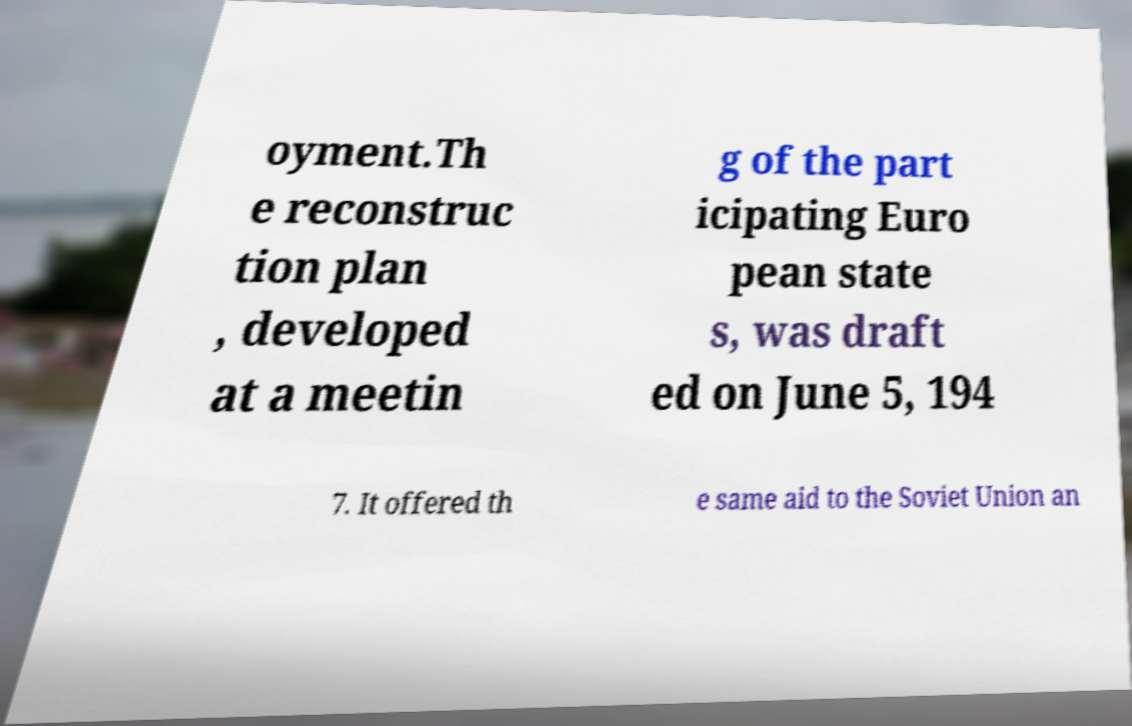Could you assist in decoding the text presented in this image and type it out clearly? oyment.Th e reconstruc tion plan , developed at a meetin g of the part icipating Euro pean state s, was draft ed on June 5, 194 7. It offered th e same aid to the Soviet Union an 